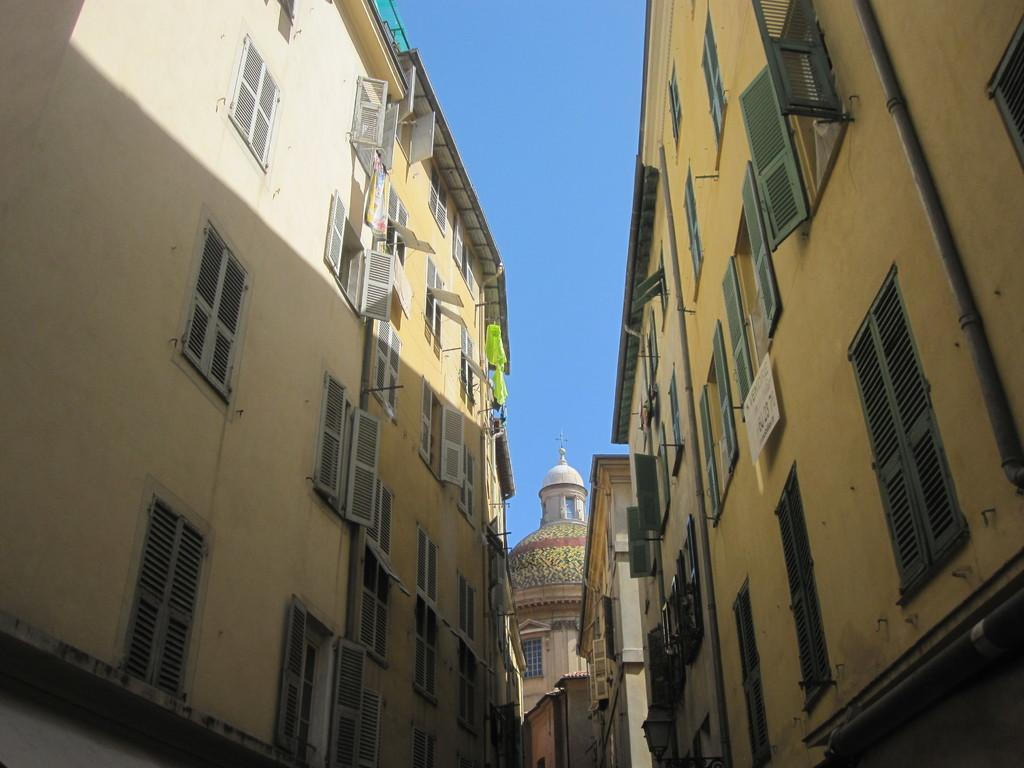What type of structures are present in the image? There are buildings in the image. What features can be observed on the buildings? The buildings have windows and pipes. What can be seen in the background of the image? The sky is visible in the background of the image. What type of song can be heard playing from the buildings in the image? There is no indication in the image that any music is playing, so it cannot be determined from the image. 